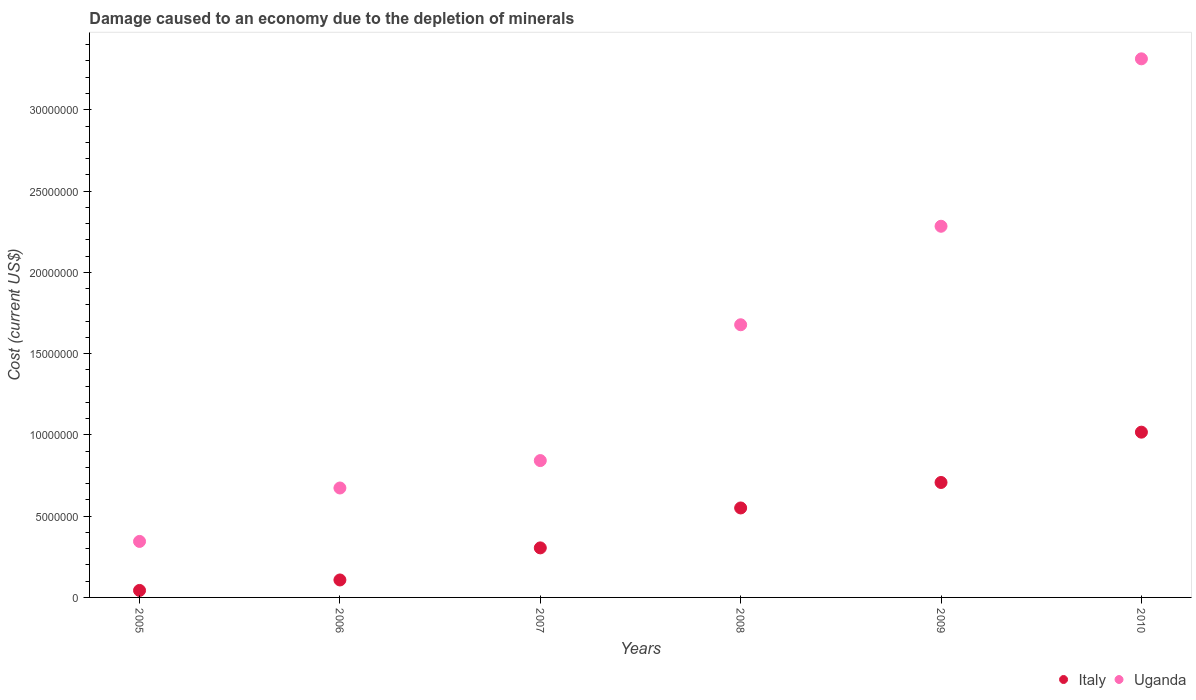How many different coloured dotlines are there?
Your response must be concise. 2. Is the number of dotlines equal to the number of legend labels?
Your answer should be compact. Yes. What is the cost of damage caused due to the depletion of minerals in Uganda in 2007?
Ensure brevity in your answer.  8.42e+06. Across all years, what is the maximum cost of damage caused due to the depletion of minerals in Uganda?
Keep it short and to the point. 3.31e+07. Across all years, what is the minimum cost of damage caused due to the depletion of minerals in Uganda?
Provide a succinct answer. 3.45e+06. In which year was the cost of damage caused due to the depletion of minerals in Italy maximum?
Provide a short and direct response. 2010. In which year was the cost of damage caused due to the depletion of minerals in Uganda minimum?
Give a very brief answer. 2005. What is the total cost of damage caused due to the depletion of minerals in Uganda in the graph?
Provide a succinct answer. 9.13e+07. What is the difference between the cost of damage caused due to the depletion of minerals in Italy in 2006 and that in 2009?
Give a very brief answer. -6.00e+06. What is the difference between the cost of damage caused due to the depletion of minerals in Uganda in 2005 and the cost of damage caused due to the depletion of minerals in Italy in 2008?
Give a very brief answer. -2.06e+06. What is the average cost of damage caused due to the depletion of minerals in Italy per year?
Offer a terse response. 4.55e+06. In the year 2010, what is the difference between the cost of damage caused due to the depletion of minerals in Italy and cost of damage caused due to the depletion of minerals in Uganda?
Your answer should be compact. -2.30e+07. What is the ratio of the cost of damage caused due to the depletion of minerals in Italy in 2007 to that in 2008?
Your answer should be very brief. 0.55. Is the difference between the cost of damage caused due to the depletion of minerals in Italy in 2005 and 2009 greater than the difference between the cost of damage caused due to the depletion of minerals in Uganda in 2005 and 2009?
Offer a terse response. Yes. What is the difference between the highest and the second highest cost of damage caused due to the depletion of minerals in Uganda?
Your response must be concise. 1.03e+07. What is the difference between the highest and the lowest cost of damage caused due to the depletion of minerals in Italy?
Keep it short and to the point. 9.74e+06. In how many years, is the cost of damage caused due to the depletion of minerals in Uganda greater than the average cost of damage caused due to the depletion of minerals in Uganda taken over all years?
Give a very brief answer. 3. Is the cost of damage caused due to the depletion of minerals in Italy strictly greater than the cost of damage caused due to the depletion of minerals in Uganda over the years?
Keep it short and to the point. No. How many years are there in the graph?
Your answer should be compact. 6. Are the values on the major ticks of Y-axis written in scientific E-notation?
Make the answer very short. No. Does the graph contain any zero values?
Ensure brevity in your answer.  No. How many legend labels are there?
Make the answer very short. 2. How are the legend labels stacked?
Ensure brevity in your answer.  Horizontal. What is the title of the graph?
Provide a succinct answer. Damage caused to an economy due to the depletion of minerals. Does "Syrian Arab Republic" appear as one of the legend labels in the graph?
Make the answer very short. No. What is the label or title of the Y-axis?
Make the answer very short. Cost (current US$). What is the Cost (current US$) of Italy in 2005?
Offer a very short reply. 4.31e+05. What is the Cost (current US$) in Uganda in 2005?
Provide a short and direct response. 3.45e+06. What is the Cost (current US$) of Italy in 2006?
Your answer should be compact. 1.07e+06. What is the Cost (current US$) of Uganda in 2006?
Provide a short and direct response. 6.73e+06. What is the Cost (current US$) of Italy in 2007?
Your response must be concise. 3.05e+06. What is the Cost (current US$) in Uganda in 2007?
Offer a terse response. 8.42e+06. What is the Cost (current US$) in Italy in 2008?
Give a very brief answer. 5.50e+06. What is the Cost (current US$) in Uganda in 2008?
Your response must be concise. 1.68e+07. What is the Cost (current US$) in Italy in 2009?
Your answer should be very brief. 7.07e+06. What is the Cost (current US$) of Uganda in 2009?
Keep it short and to the point. 2.28e+07. What is the Cost (current US$) in Italy in 2010?
Offer a very short reply. 1.02e+07. What is the Cost (current US$) of Uganda in 2010?
Offer a very short reply. 3.31e+07. Across all years, what is the maximum Cost (current US$) in Italy?
Offer a very short reply. 1.02e+07. Across all years, what is the maximum Cost (current US$) in Uganda?
Your answer should be compact. 3.31e+07. Across all years, what is the minimum Cost (current US$) of Italy?
Keep it short and to the point. 4.31e+05. Across all years, what is the minimum Cost (current US$) of Uganda?
Give a very brief answer. 3.45e+06. What is the total Cost (current US$) in Italy in the graph?
Your answer should be very brief. 2.73e+07. What is the total Cost (current US$) in Uganda in the graph?
Provide a short and direct response. 9.13e+07. What is the difference between the Cost (current US$) of Italy in 2005 and that in 2006?
Provide a short and direct response. -6.44e+05. What is the difference between the Cost (current US$) of Uganda in 2005 and that in 2006?
Ensure brevity in your answer.  -3.29e+06. What is the difference between the Cost (current US$) in Italy in 2005 and that in 2007?
Give a very brief answer. -2.62e+06. What is the difference between the Cost (current US$) in Uganda in 2005 and that in 2007?
Ensure brevity in your answer.  -4.97e+06. What is the difference between the Cost (current US$) in Italy in 2005 and that in 2008?
Ensure brevity in your answer.  -5.07e+06. What is the difference between the Cost (current US$) in Uganda in 2005 and that in 2008?
Ensure brevity in your answer.  -1.33e+07. What is the difference between the Cost (current US$) of Italy in 2005 and that in 2009?
Offer a very short reply. -6.64e+06. What is the difference between the Cost (current US$) of Uganda in 2005 and that in 2009?
Give a very brief answer. -1.94e+07. What is the difference between the Cost (current US$) in Italy in 2005 and that in 2010?
Provide a succinct answer. -9.74e+06. What is the difference between the Cost (current US$) of Uganda in 2005 and that in 2010?
Provide a succinct answer. -2.97e+07. What is the difference between the Cost (current US$) in Italy in 2006 and that in 2007?
Offer a terse response. -1.97e+06. What is the difference between the Cost (current US$) in Uganda in 2006 and that in 2007?
Offer a terse response. -1.69e+06. What is the difference between the Cost (current US$) of Italy in 2006 and that in 2008?
Provide a short and direct response. -4.43e+06. What is the difference between the Cost (current US$) of Uganda in 2006 and that in 2008?
Provide a succinct answer. -1.00e+07. What is the difference between the Cost (current US$) in Italy in 2006 and that in 2009?
Make the answer very short. -6.00e+06. What is the difference between the Cost (current US$) in Uganda in 2006 and that in 2009?
Make the answer very short. -1.61e+07. What is the difference between the Cost (current US$) in Italy in 2006 and that in 2010?
Provide a succinct answer. -9.09e+06. What is the difference between the Cost (current US$) in Uganda in 2006 and that in 2010?
Your answer should be very brief. -2.64e+07. What is the difference between the Cost (current US$) of Italy in 2007 and that in 2008?
Keep it short and to the point. -2.46e+06. What is the difference between the Cost (current US$) of Uganda in 2007 and that in 2008?
Make the answer very short. -8.36e+06. What is the difference between the Cost (current US$) of Italy in 2007 and that in 2009?
Provide a short and direct response. -4.02e+06. What is the difference between the Cost (current US$) of Uganda in 2007 and that in 2009?
Your answer should be very brief. -1.44e+07. What is the difference between the Cost (current US$) in Italy in 2007 and that in 2010?
Provide a short and direct response. -7.12e+06. What is the difference between the Cost (current US$) of Uganda in 2007 and that in 2010?
Your answer should be very brief. -2.47e+07. What is the difference between the Cost (current US$) of Italy in 2008 and that in 2009?
Your response must be concise. -1.57e+06. What is the difference between the Cost (current US$) of Uganda in 2008 and that in 2009?
Your response must be concise. -6.06e+06. What is the difference between the Cost (current US$) of Italy in 2008 and that in 2010?
Make the answer very short. -4.66e+06. What is the difference between the Cost (current US$) in Uganda in 2008 and that in 2010?
Offer a terse response. -1.64e+07. What is the difference between the Cost (current US$) of Italy in 2009 and that in 2010?
Provide a short and direct response. -3.09e+06. What is the difference between the Cost (current US$) in Uganda in 2009 and that in 2010?
Keep it short and to the point. -1.03e+07. What is the difference between the Cost (current US$) in Italy in 2005 and the Cost (current US$) in Uganda in 2006?
Your answer should be very brief. -6.30e+06. What is the difference between the Cost (current US$) in Italy in 2005 and the Cost (current US$) in Uganda in 2007?
Your answer should be very brief. -7.99e+06. What is the difference between the Cost (current US$) in Italy in 2005 and the Cost (current US$) in Uganda in 2008?
Your response must be concise. -1.63e+07. What is the difference between the Cost (current US$) in Italy in 2005 and the Cost (current US$) in Uganda in 2009?
Offer a very short reply. -2.24e+07. What is the difference between the Cost (current US$) of Italy in 2005 and the Cost (current US$) of Uganda in 2010?
Give a very brief answer. -3.27e+07. What is the difference between the Cost (current US$) of Italy in 2006 and the Cost (current US$) of Uganda in 2007?
Offer a terse response. -7.34e+06. What is the difference between the Cost (current US$) in Italy in 2006 and the Cost (current US$) in Uganda in 2008?
Your answer should be compact. -1.57e+07. What is the difference between the Cost (current US$) in Italy in 2006 and the Cost (current US$) in Uganda in 2009?
Your answer should be compact. -2.18e+07. What is the difference between the Cost (current US$) of Italy in 2006 and the Cost (current US$) of Uganda in 2010?
Your response must be concise. -3.21e+07. What is the difference between the Cost (current US$) of Italy in 2007 and the Cost (current US$) of Uganda in 2008?
Provide a succinct answer. -1.37e+07. What is the difference between the Cost (current US$) of Italy in 2007 and the Cost (current US$) of Uganda in 2009?
Make the answer very short. -1.98e+07. What is the difference between the Cost (current US$) of Italy in 2007 and the Cost (current US$) of Uganda in 2010?
Your answer should be compact. -3.01e+07. What is the difference between the Cost (current US$) of Italy in 2008 and the Cost (current US$) of Uganda in 2009?
Provide a succinct answer. -1.73e+07. What is the difference between the Cost (current US$) in Italy in 2008 and the Cost (current US$) in Uganda in 2010?
Give a very brief answer. -2.76e+07. What is the difference between the Cost (current US$) in Italy in 2009 and the Cost (current US$) in Uganda in 2010?
Your answer should be very brief. -2.61e+07. What is the average Cost (current US$) in Italy per year?
Offer a terse response. 4.55e+06. What is the average Cost (current US$) in Uganda per year?
Ensure brevity in your answer.  1.52e+07. In the year 2005, what is the difference between the Cost (current US$) in Italy and Cost (current US$) in Uganda?
Offer a terse response. -3.01e+06. In the year 2006, what is the difference between the Cost (current US$) of Italy and Cost (current US$) of Uganda?
Provide a short and direct response. -5.66e+06. In the year 2007, what is the difference between the Cost (current US$) in Italy and Cost (current US$) in Uganda?
Keep it short and to the point. -5.37e+06. In the year 2008, what is the difference between the Cost (current US$) in Italy and Cost (current US$) in Uganda?
Your answer should be very brief. -1.13e+07. In the year 2009, what is the difference between the Cost (current US$) in Italy and Cost (current US$) in Uganda?
Offer a very short reply. -1.58e+07. In the year 2010, what is the difference between the Cost (current US$) of Italy and Cost (current US$) of Uganda?
Your response must be concise. -2.30e+07. What is the ratio of the Cost (current US$) in Italy in 2005 to that in 2006?
Give a very brief answer. 0.4. What is the ratio of the Cost (current US$) of Uganda in 2005 to that in 2006?
Provide a succinct answer. 0.51. What is the ratio of the Cost (current US$) in Italy in 2005 to that in 2007?
Make the answer very short. 0.14. What is the ratio of the Cost (current US$) of Uganda in 2005 to that in 2007?
Provide a short and direct response. 0.41. What is the ratio of the Cost (current US$) in Italy in 2005 to that in 2008?
Offer a terse response. 0.08. What is the ratio of the Cost (current US$) in Uganda in 2005 to that in 2008?
Provide a short and direct response. 0.21. What is the ratio of the Cost (current US$) of Italy in 2005 to that in 2009?
Provide a short and direct response. 0.06. What is the ratio of the Cost (current US$) of Uganda in 2005 to that in 2009?
Provide a short and direct response. 0.15. What is the ratio of the Cost (current US$) in Italy in 2005 to that in 2010?
Make the answer very short. 0.04. What is the ratio of the Cost (current US$) of Uganda in 2005 to that in 2010?
Provide a succinct answer. 0.1. What is the ratio of the Cost (current US$) of Italy in 2006 to that in 2007?
Your answer should be compact. 0.35. What is the ratio of the Cost (current US$) in Uganda in 2006 to that in 2007?
Give a very brief answer. 0.8. What is the ratio of the Cost (current US$) in Italy in 2006 to that in 2008?
Provide a succinct answer. 0.2. What is the ratio of the Cost (current US$) of Uganda in 2006 to that in 2008?
Your response must be concise. 0.4. What is the ratio of the Cost (current US$) in Italy in 2006 to that in 2009?
Your answer should be very brief. 0.15. What is the ratio of the Cost (current US$) of Uganda in 2006 to that in 2009?
Give a very brief answer. 0.29. What is the ratio of the Cost (current US$) of Italy in 2006 to that in 2010?
Offer a terse response. 0.11. What is the ratio of the Cost (current US$) in Uganda in 2006 to that in 2010?
Provide a short and direct response. 0.2. What is the ratio of the Cost (current US$) of Italy in 2007 to that in 2008?
Offer a very short reply. 0.55. What is the ratio of the Cost (current US$) of Uganda in 2007 to that in 2008?
Your answer should be very brief. 0.5. What is the ratio of the Cost (current US$) of Italy in 2007 to that in 2009?
Give a very brief answer. 0.43. What is the ratio of the Cost (current US$) in Uganda in 2007 to that in 2009?
Offer a very short reply. 0.37. What is the ratio of the Cost (current US$) in Italy in 2007 to that in 2010?
Provide a short and direct response. 0.3. What is the ratio of the Cost (current US$) of Uganda in 2007 to that in 2010?
Your answer should be compact. 0.25. What is the ratio of the Cost (current US$) in Italy in 2008 to that in 2009?
Provide a short and direct response. 0.78. What is the ratio of the Cost (current US$) in Uganda in 2008 to that in 2009?
Offer a very short reply. 0.73. What is the ratio of the Cost (current US$) in Italy in 2008 to that in 2010?
Your answer should be compact. 0.54. What is the ratio of the Cost (current US$) in Uganda in 2008 to that in 2010?
Your answer should be very brief. 0.51. What is the ratio of the Cost (current US$) of Italy in 2009 to that in 2010?
Provide a succinct answer. 0.7. What is the ratio of the Cost (current US$) of Uganda in 2009 to that in 2010?
Keep it short and to the point. 0.69. What is the difference between the highest and the second highest Cost (current US$) in Italy?
Provide a short and direct response. 3.09e+06. What is the difference between the highest and the second highest Cost (current US$) in Uganda?
Give a very brief answer. 1.03e+07. What is the difference between the highest and the lowest Cost (current US$) in Italy?
Ensure brevity in your answer.  9.74e+06. What is the difference between the highest and the lowest Cost (current US$) in Uganda?
Keep it short and to the point. 2.97e+07. 